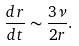Convert formula to latex. <formula><loc_0><loc_0><loc_500><loc_500>\frac { d r } { d t } \sim \frac { 3 \nu } { 2 r } .</formula> 